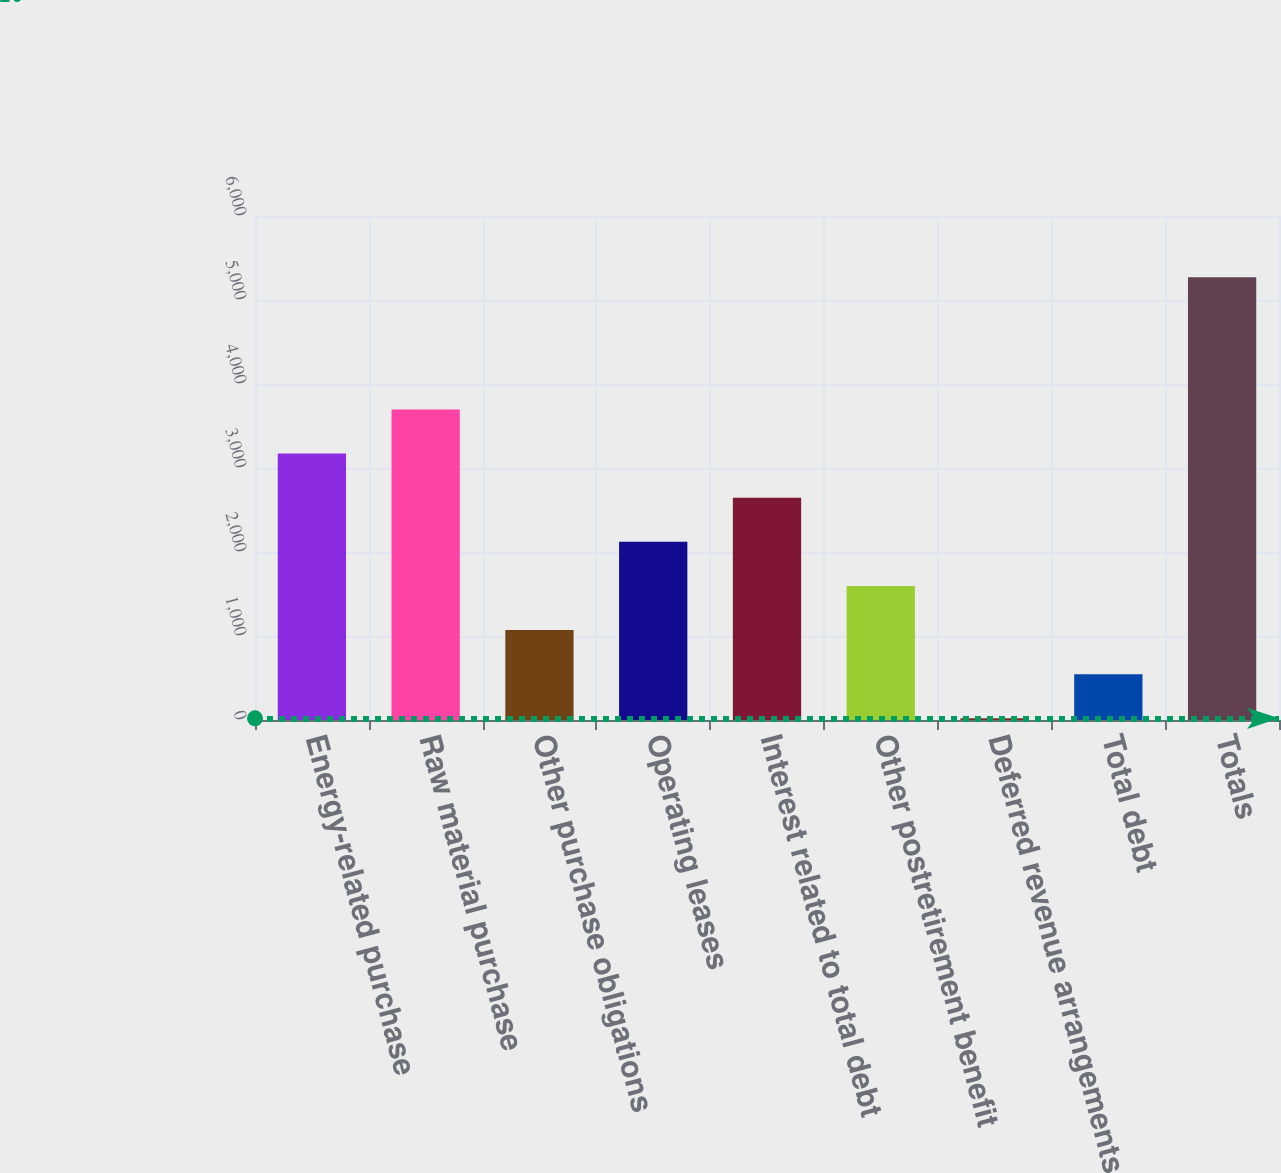Convert chart. <chart><loc_0><loc_0><loc_500><loc_500><bar_chart><fcel>Energy-related purchase<fcel>Raw material purchase<fcel>Other purchase obligations<fcel>Operating leases<fcel>Interest related to total debt<fcel>Other postretirement benefit<fcel>Deferred revenue arrangements<fcel>Total debt<fcel>Totals<nl><fcel>3171.2<fcel>3696.4<fcel>1070.4<fcel>2120.8<fcel>2646<fcel>1595.6<fcel>20<fcel>545.2<fcel>5272<nl></chart> 